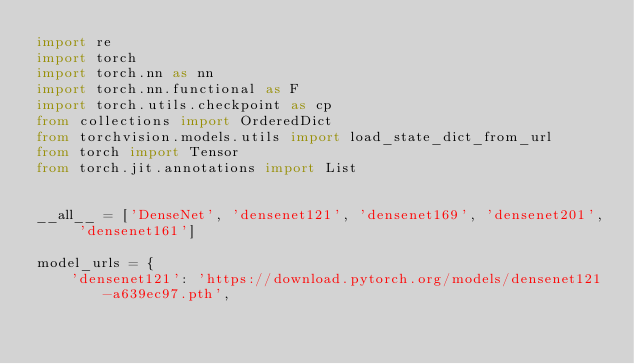<code> <loc_0><loc_0><loc_500><loc_500><_Python_>import re
import torch
import torch.nn as nn
import torch.nn.functional as F
import torch.utils.checkpoint as cp
from collections import OrderedDict
from torchvision.models.utils import load_state_dict_from_url
from torch import Tensor
from torch.jit.annotations import List


__all__ = ['DenseNet', 'densenet121', 'densenet169', 'densenet201', 'densenet161']

model_urls = {
    'densenet121': 'https://download.pytorch.org/models/densenet121-a639ec97.pth',</code> 